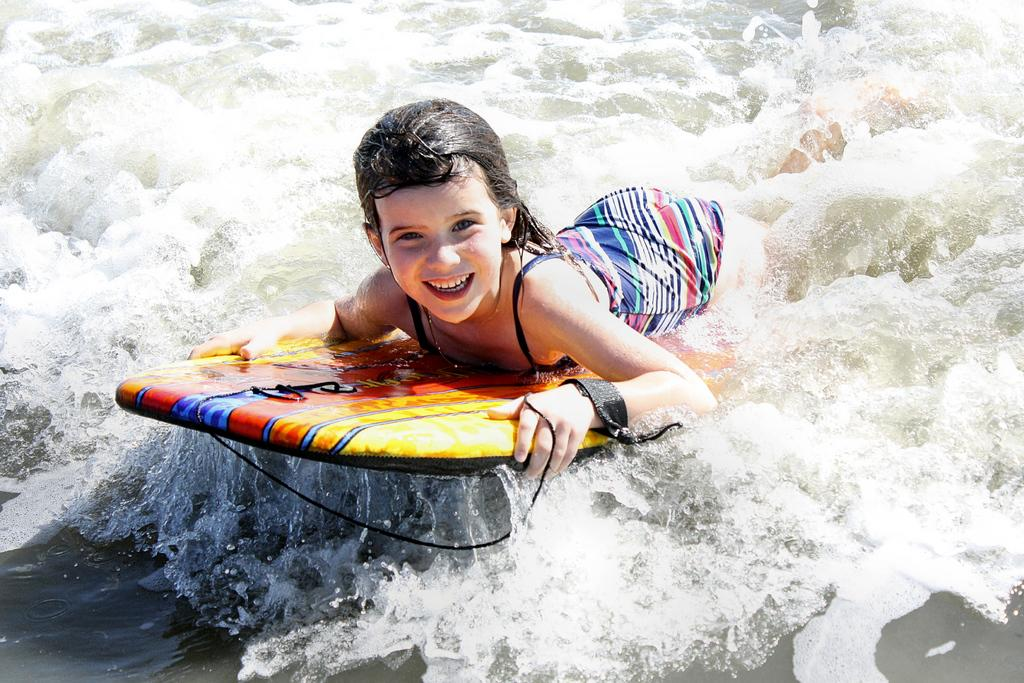Who is the main subject in the image? There is a girl in the image. What is the girl doing in the image? The girl is in the water and using a surfboard for support. How does the girl feel in the image? The girl is smiling, which suggests she is happy or enjoying herself. What type of request is the girl making in the image? There is no indication in the image that the girl is making any request. 